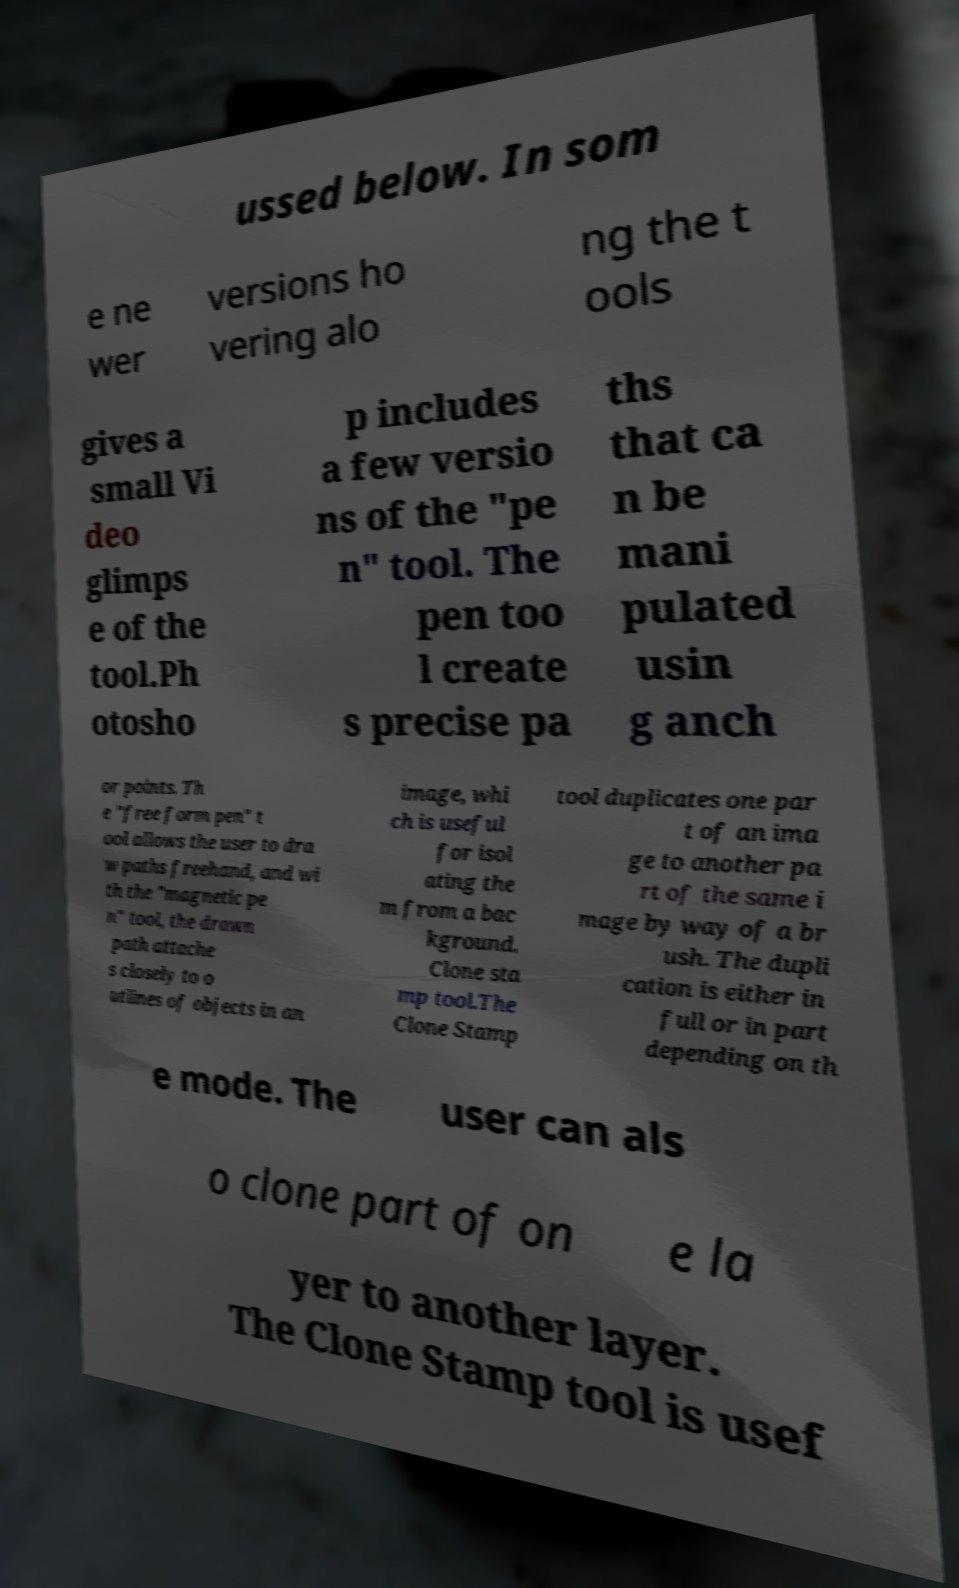For documentation purposes, I need the text within this image transcribed. Could you provide that? ussed below. In som e ne wer versions ho vering alo ng the t ools gives a small Vi deo glimps e of the tool.Ph otosho p includes a few versio ns of the "pe n" tool. The pen too l create s precise pa ths that ca n be mani pulated usin g anch or points. Th e "free form pen" t ool allows the user to dra w paths freehand, and wi th the "magnetic pe n" tool, the drawn path attache s closely to o utlines of objects in an image, whi ch is useful for isol ating the m from a bac kground. Clone sta mp tool.The Clone Stamp tool duplicates one par t of an ima ge to another pa rt of the same i mage by way of a br ush. The dupli cation is either in full or in part depending on th e mode. The user can als o clone part of on e la yer to another layer. The Clone Stamp tool is usef 